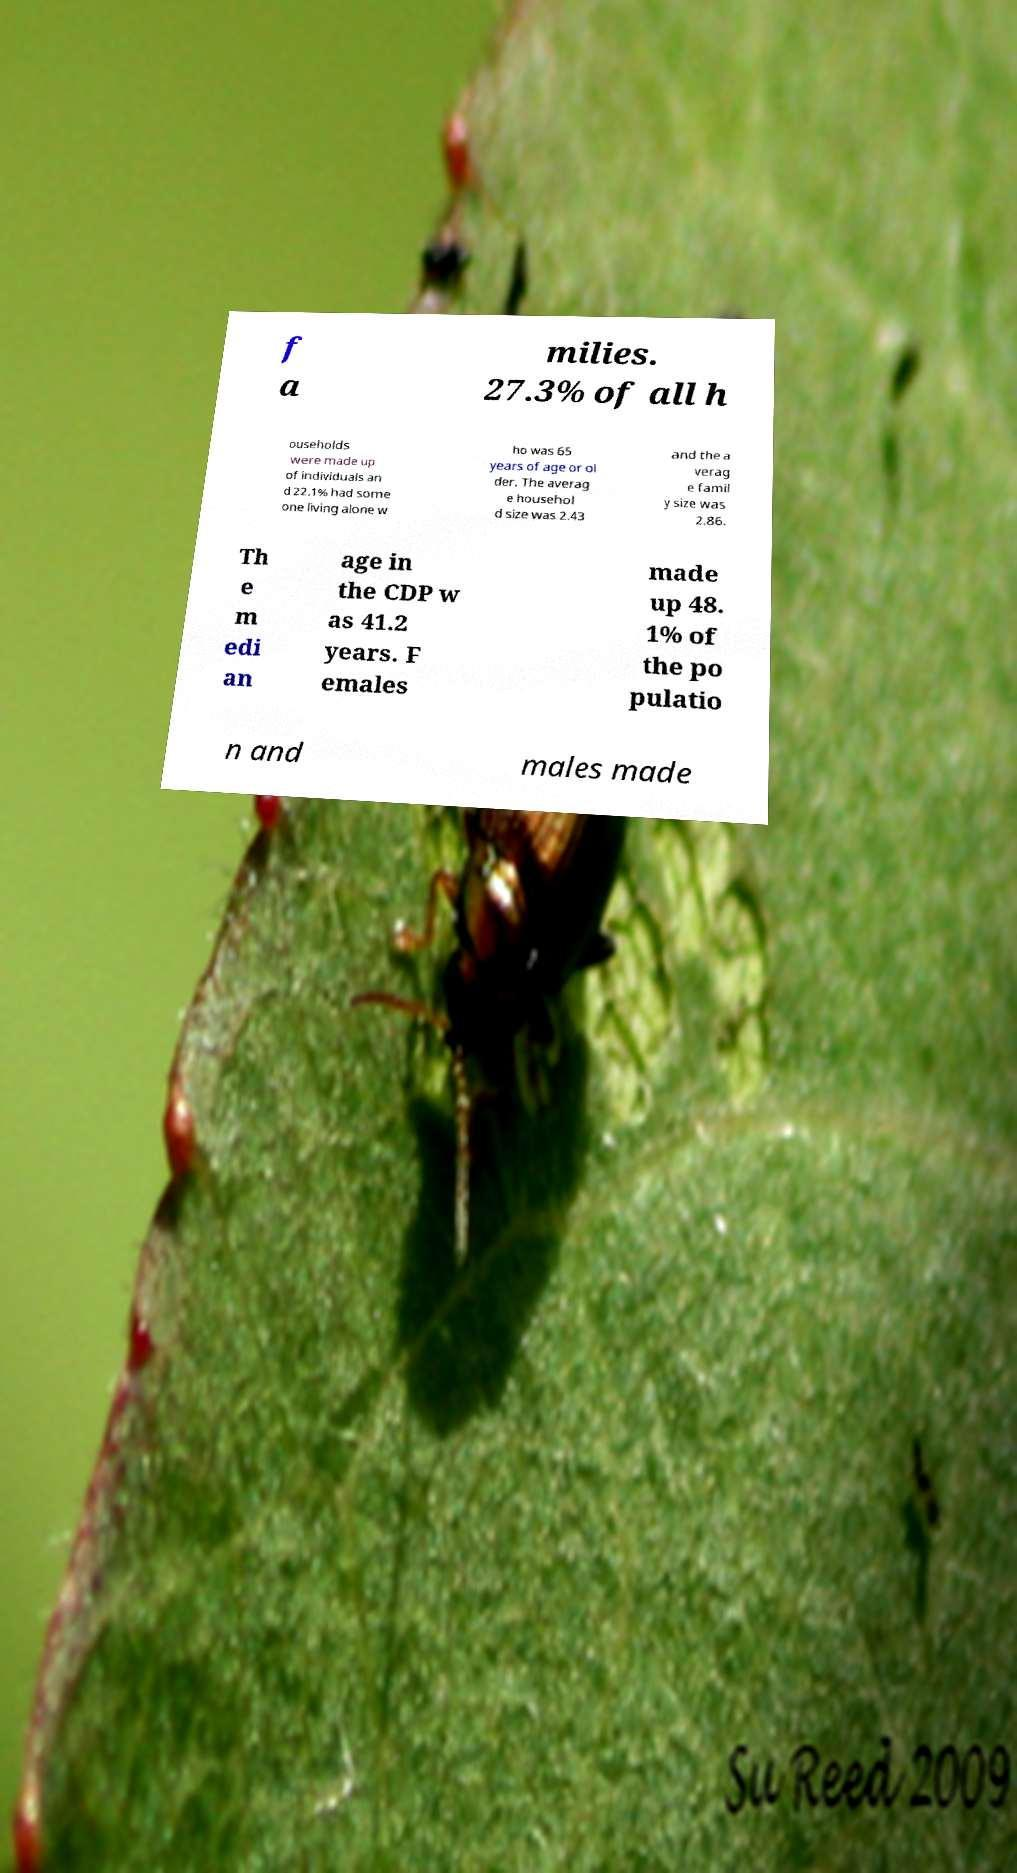What messages or text are displayed in this image? I need them in a readable, typed format. f a milies. 27.3% of all h ouseholds were made up of individuals an d 22.1% had some one living alone w ho was 65 years of age or ol der. The averag e househol d size was 2.43 and the a verag e famil y size was 2.86. Th e m edi an age in the CDP w as 41.2 years. F emales made up 48. 1% of the po pulatio n and males made 